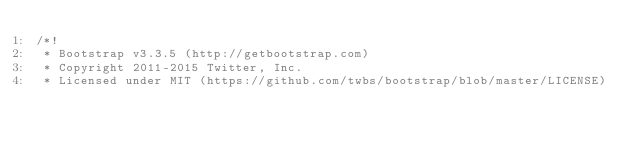<code> <loc_0><loc_0><loc_500><loc_500><_CSS_>/*!
 * Bootstrap v3.3.5 (http://getbootstrap.com)
 * Copyright 2011-2015 Twitter, Inc.
 * Licensed under MIT (https://github.com/twbs/bootstrap/blob/master/LICENSE)</code> 